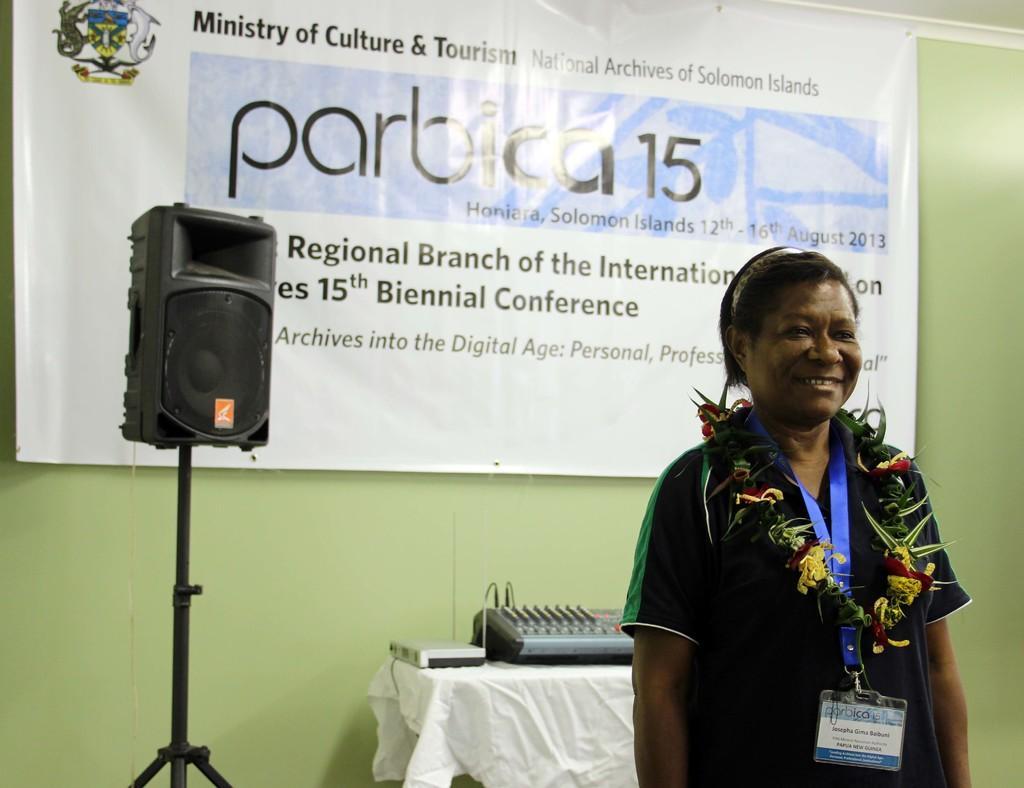Can you describe this image briefly? In this image we can see a person standing and smiling. On the right there is a speaker. In the background there is a table and we can see some objects placed on the table. There is a banner and we can see a wall. 